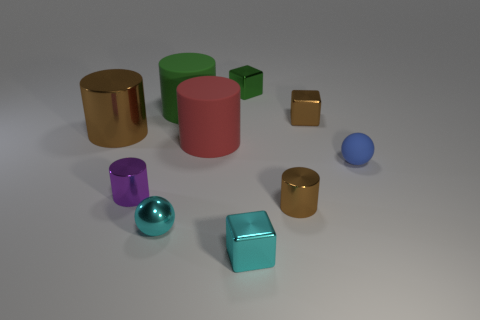Subtract all purple cylinders. How many cylinders are left? 4 Subtract all balls. How many objects are left? 8 Subtract all cyan blocks. How many blocks are left? 2 Subtract 2 cylinders. How many cylinders are left? 3 Subtract all green cubes. Subtract all purple cylinders. How many cubes are left? 2 Subtract all purple cylinders. How many green blocks are left? 1 Subtract all big brown metal balls. Subtract all large red things. How many objects are left? 9 Add 5 rubber cylinders. How many rubber cylinders are left? 7 Add 2 brown rubber things. How many brown rubber things exist? 2 Subtract 0 blue blocks. How many objects are left? 10 